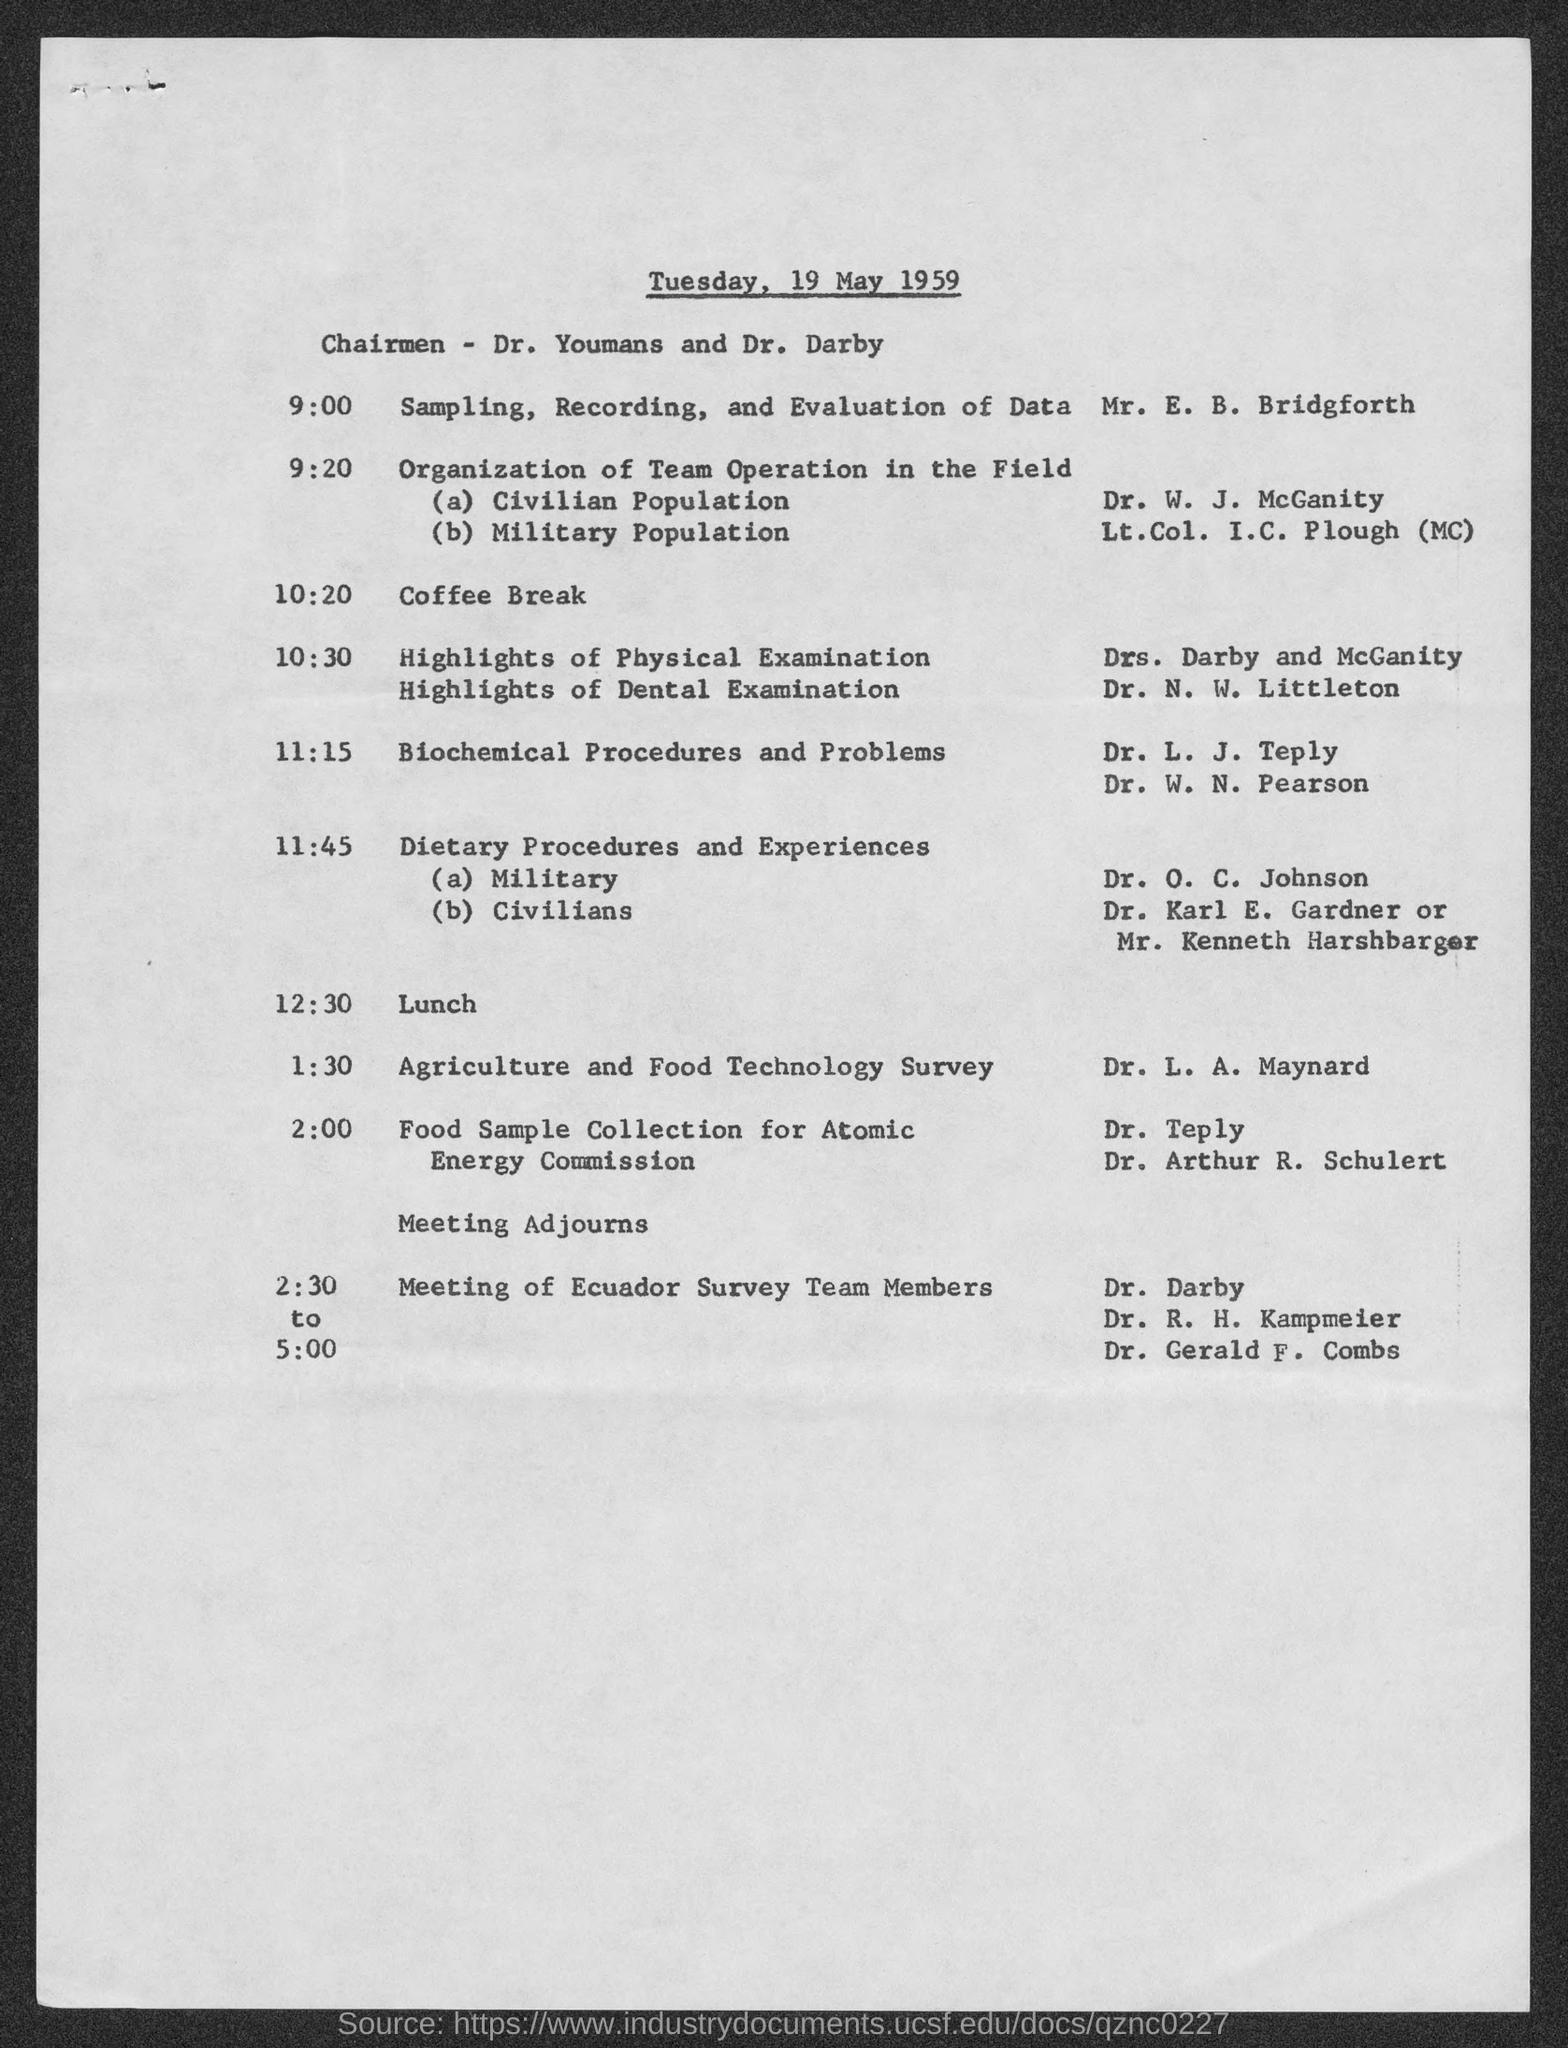When was this meeting organised?
Make the answer very short. Tuesday, 19 may 1959. Who was the Chairmen?
Provide a succinct answer. Dr. Youmans and Dr. Darby. Whats the time Agriculture and Food Technology Survey discussed?
Your answer should be very brief. 1:30. What was the topic of Dr. N. W. Littleton?
Offer a terse response. Highlights of dental examination. Whats the time for Lunch?
Your answer should be compact. 12:30. Sampling, Recording and Evaluation of Data was done by?
Offer a terse response. Mr. e. b. bridgforth. When the meeting was ended up?
Give a very brief answer. 5:00. 